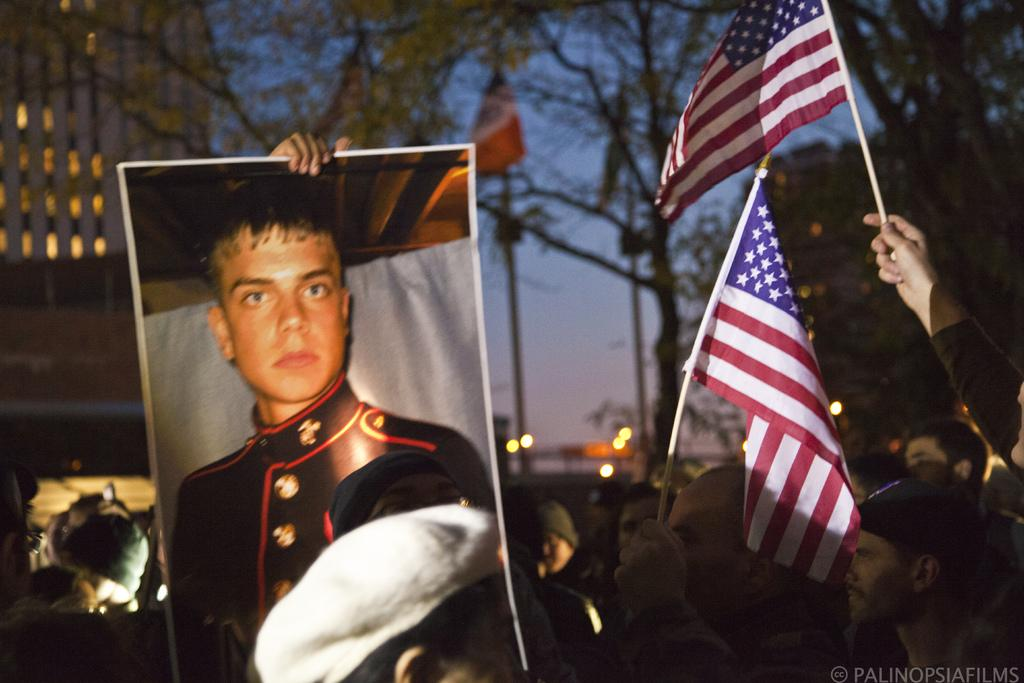What is the main subject of the image? The main subject of the image is a group of people. What are some of the people holding in the image? Some people are holding US flags in the image. What can be seen in the background of the image? There are many trees in the background of the image. What type of structure is present in the image? There is a building in the image. What is the wealth of the representative in the image? There is no representative present in the image, and therefore no wealth can be attributed to them. Can you tell me how the plough is being used in the image? There is no plough present in the image, so it cannot be used or observed. 